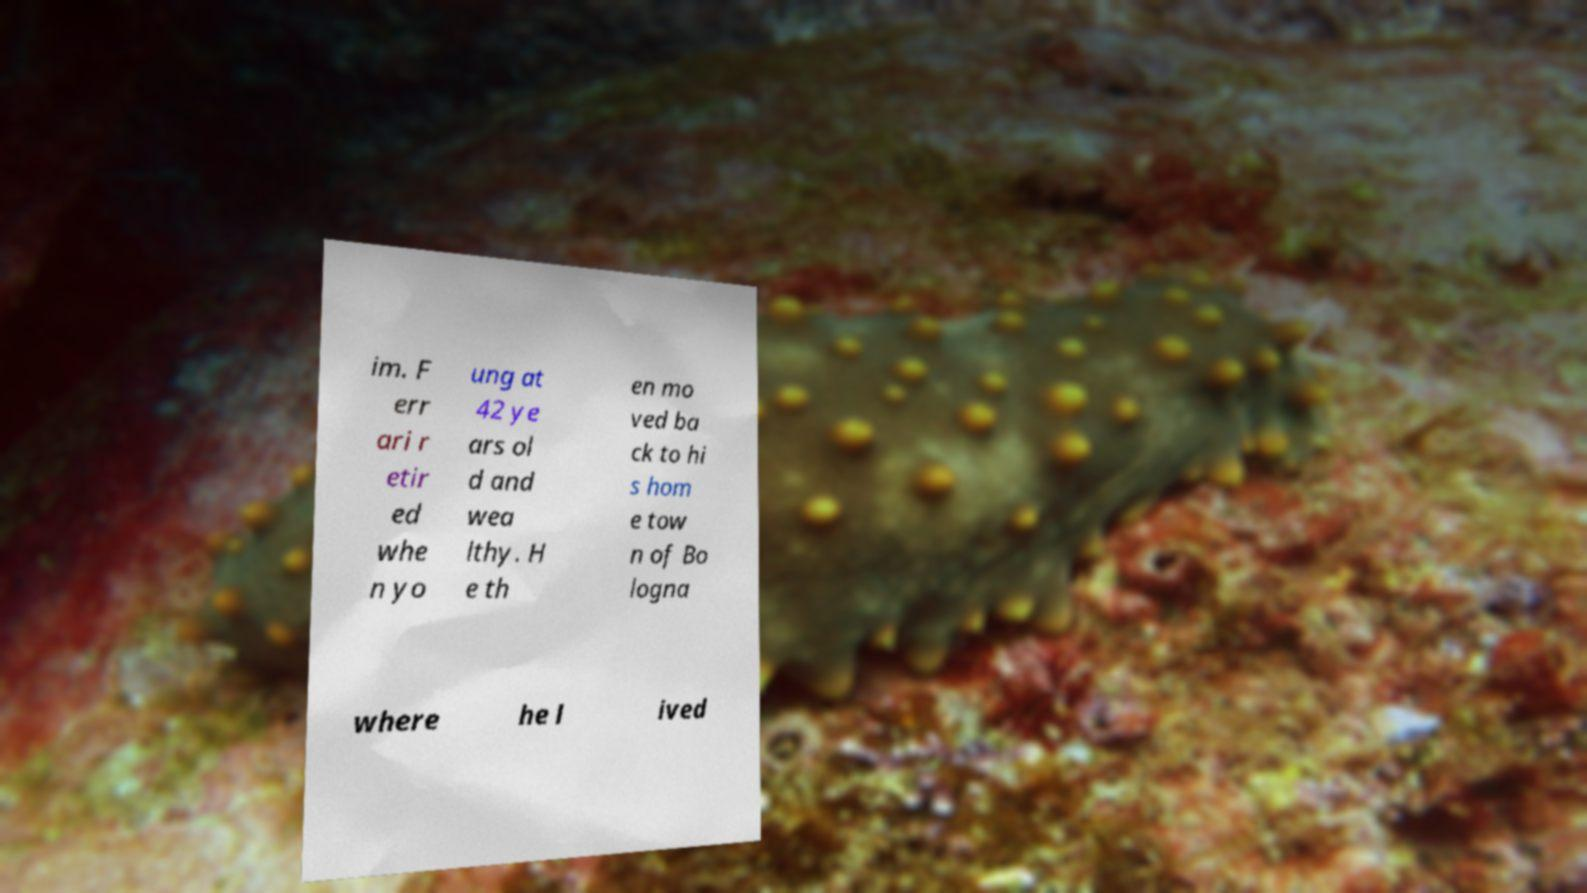There's text embedded in this image that I need extracted. Can you transcribe it verbatim? im. F err ari r etir ed whe n yo ung at 42 ye ars ol d and wea lthy. H e th en mo ved ba ck to hi s hom e tow n of Bo logna where he l ived 